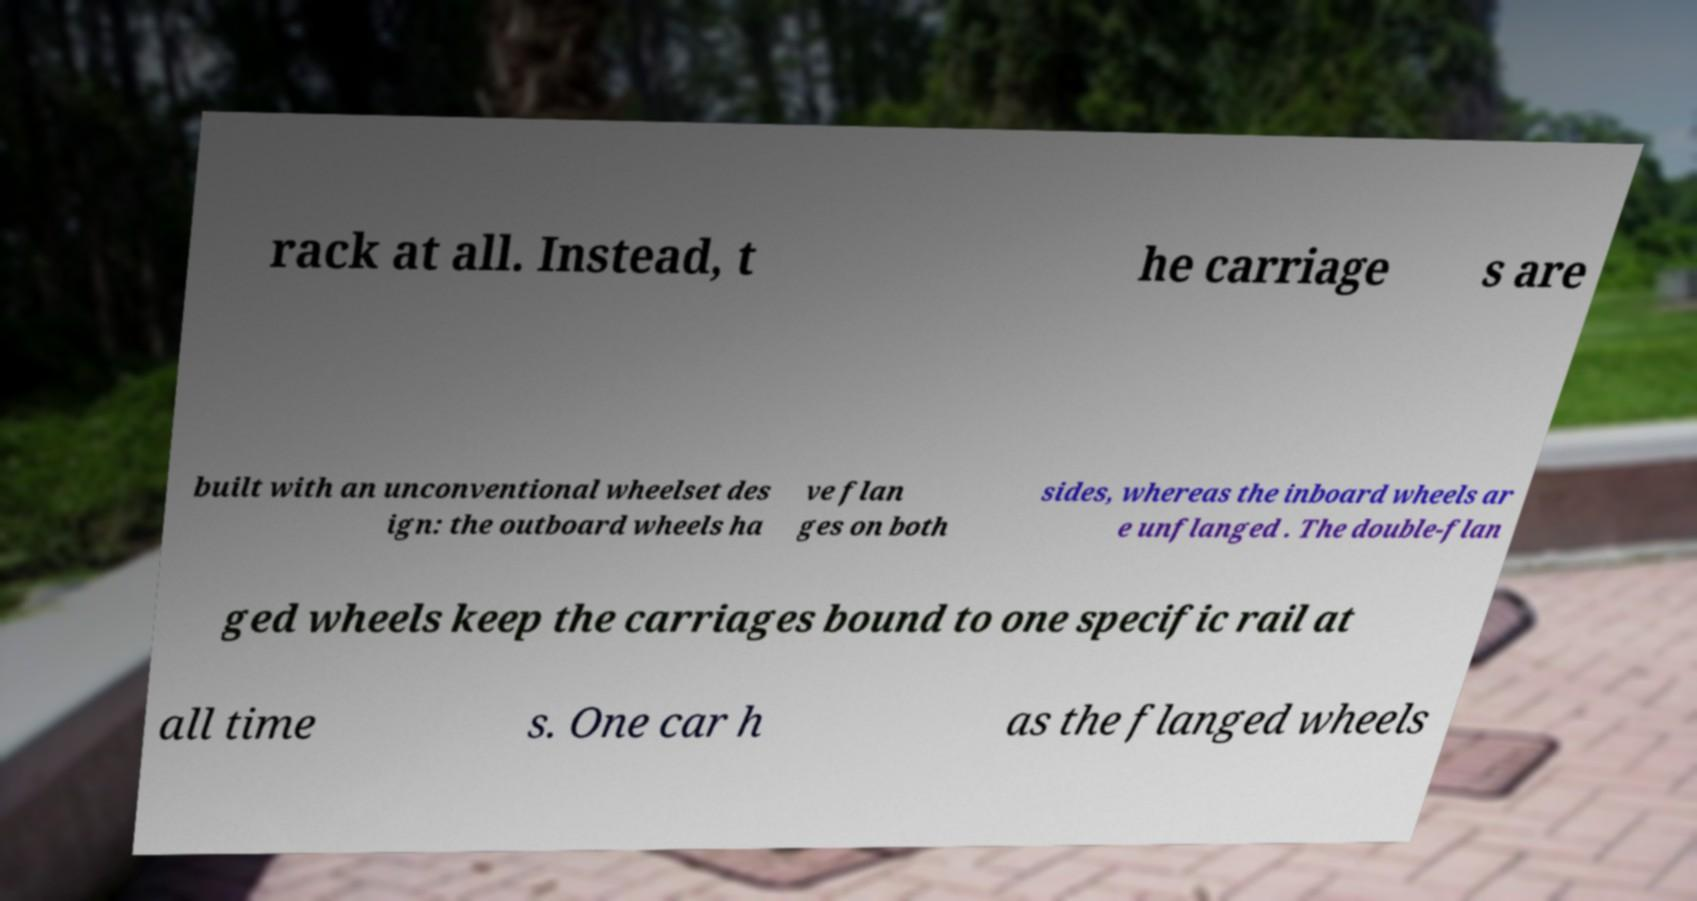Can you accurately transcribe the text from the provided image for me? rack at all. Instead, t he carriage s are built with an unconventional wheelset des ign: the outboard wheels ha ve flan ges on both sides, whereas the inboard wheels ar e unflanged . The double-flan ged wheels keep the carriages bound to one specific rail at all time s. One car h as the flanged wheels 